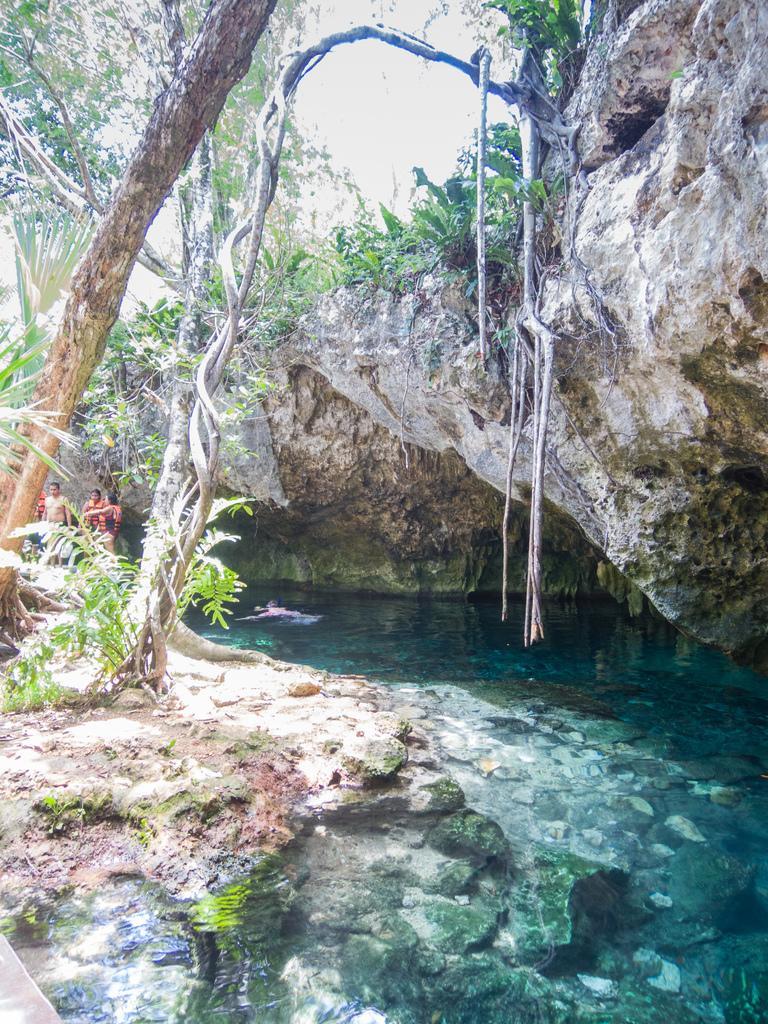Can you describe this image briefly? This picture is clicked near a cave. There are rocks, trees, water and plants in the image. There are aerial roots to the tree. In the background there are few people standing.  